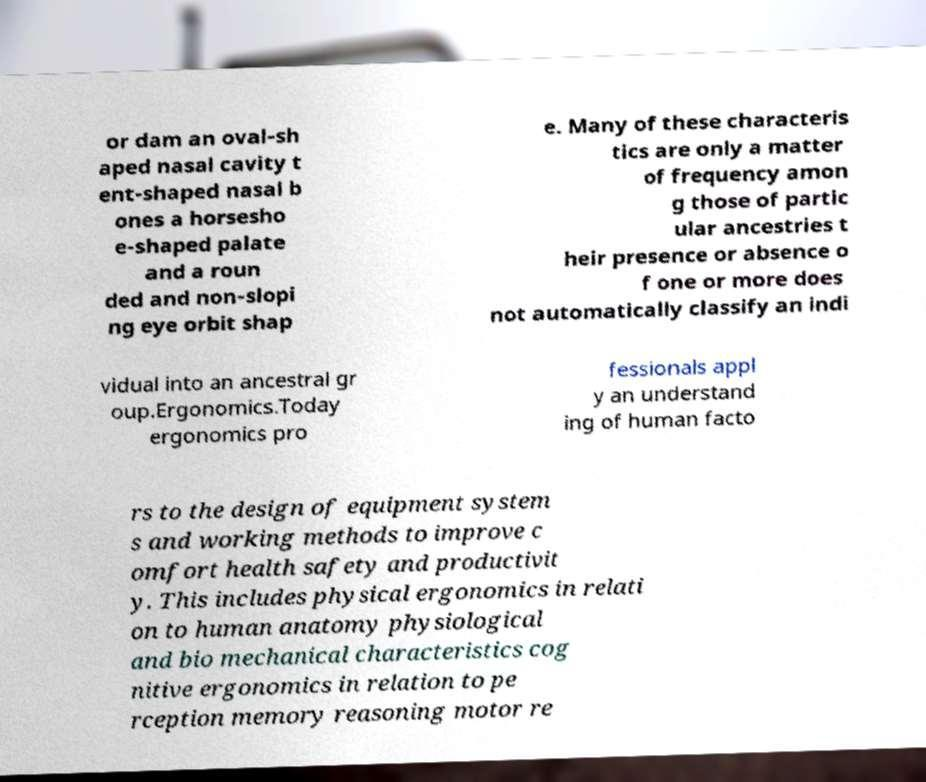There's text embedded in this image that I need extracted. Can you transcribe it verbatim? or dam an oval-sh aped nasal cavity t ent-shaped nasal b ones a horsesho e-shaped palate and a roun ded and non-slopi ng eye orbit shap e. Many of these characteris tics are only a matter of frequency amon g those of partic ular ancestries t heir presence or absence o f one or more does not automatically classify an indi vidual into an ancestral gr oup.Ergonomics.Today ergonomics pro fessionals appl y an understand ing of human facto rs to the design of equipment system s and working methods to improve c omfort health safety and productivit y. This includes physical ergonomics in relati on to human anatomy physiological and bio mechanical characteristics cog nitive ergonomics in relation to pe rception memory reasoning motor re 